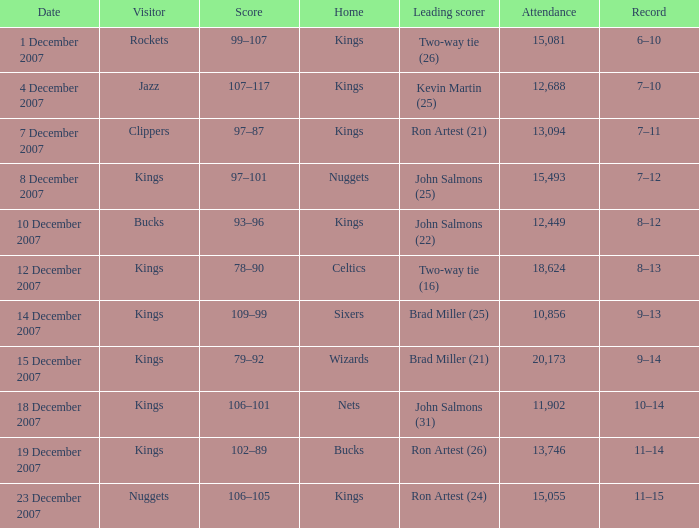What was the record of the game where the Rockets were the visiting team? 6–10. 